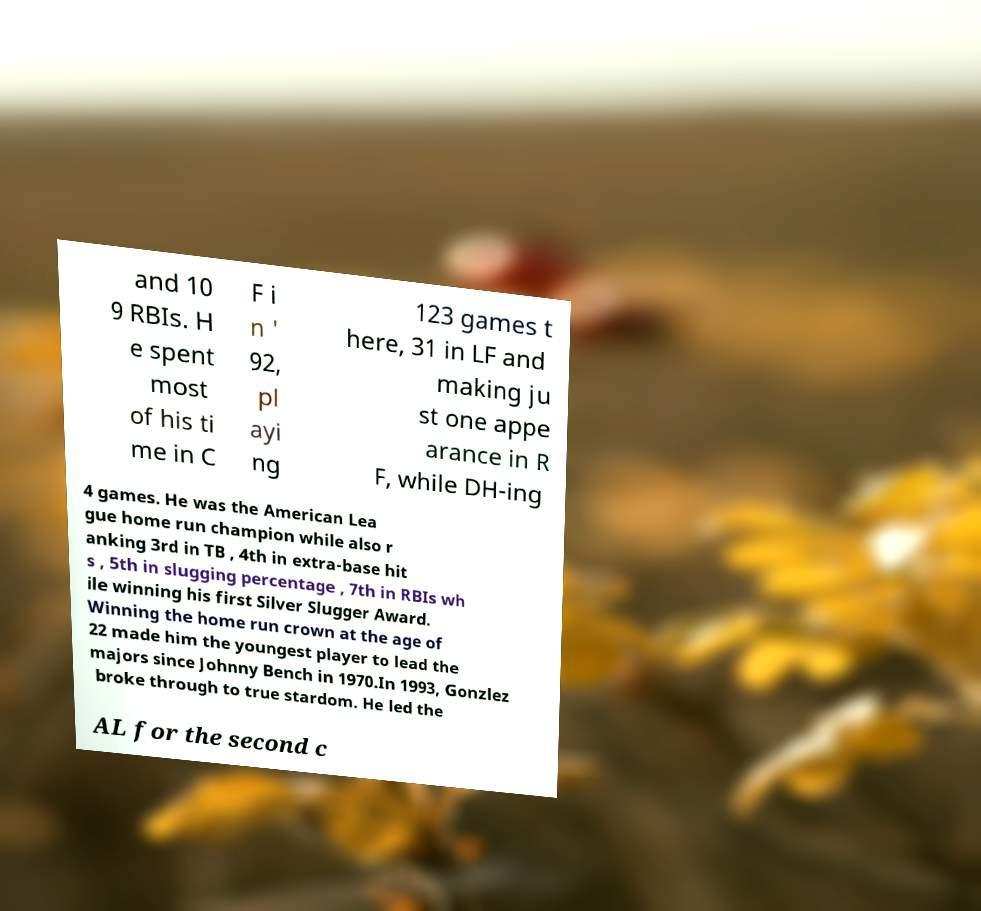Can you read and provide the text displayed in the image?This photo seems to have some interesting text. Can you extract and type it out for me? and 10 9 RBIs. H e spent most of his ti me in C F i n ' 92, pl ayi ng 123 games t here, 31 in LF and making ju st one appe arance in R F, while DH-ing 4 games. He was the American Lea gue home run champion while also r anking 3rd in TB , 4th in extra-base hit s , 5th in slugging percentage , 7th in RBIs wh ile winning his first Silver Slugger Award. Winning the home run crown at the age of 22 made him the youngest player to lead the majors since Johnny Bench in 1970.In 1993, Gonzlez broke through to true stardom. He led the AL for the second c 